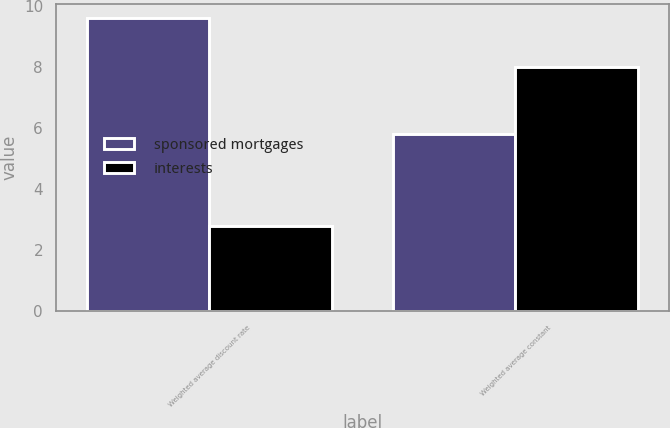Convert chart to OTSL. <chart><loc_0><loc_0><loc_500><loc_500><stacked_bar_chart><ecel><fcel>Weighted average discount rate<fcel>Weighted average constant<nl><fcel>sponsored mortgages<fcel>9.6<fcel>5.8<nl><fcel>interests<fcel>2.8<fcel>8<nl></chart> 